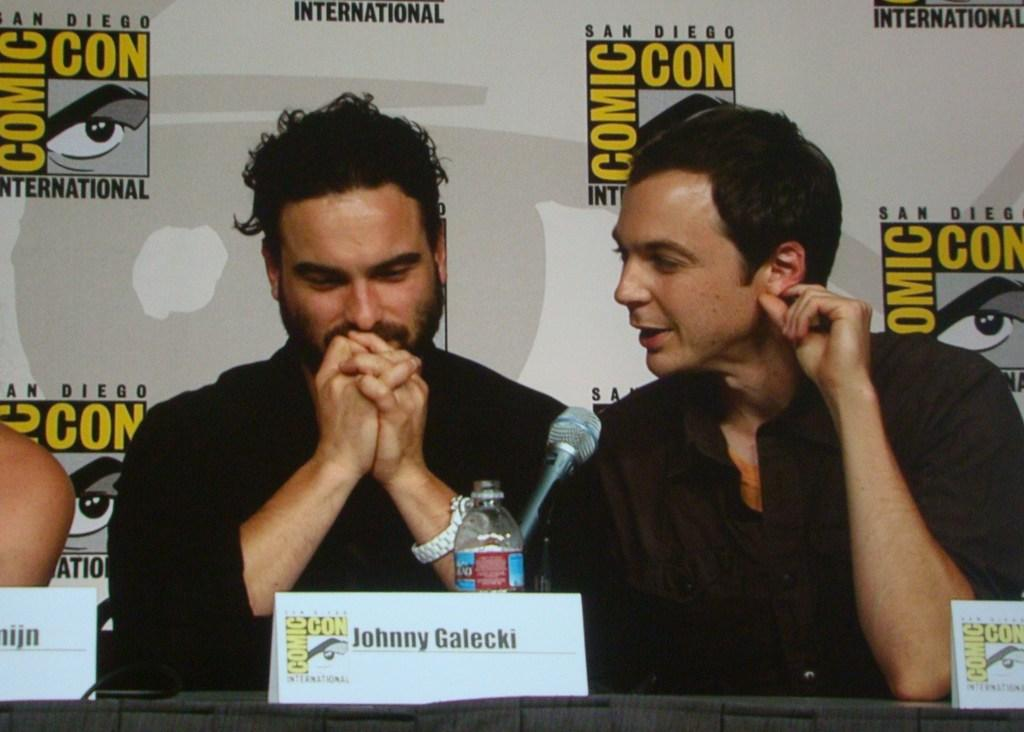Who or what can be seen in the image? There are people in the image. What objects are present in the image besides the people? There are boards, a bottle, a microphone, and a banner in the background of the image. What street is visible in the image? There is no street visible in the image. How many adjustments are needed to make the bottle stand upright in the image? The image does not show the bottle in a position that requires adjustment; it is already standing upright. 